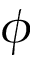<formula> <loc_0><loc_0><loc_500><loc_500>\phi</formula> 